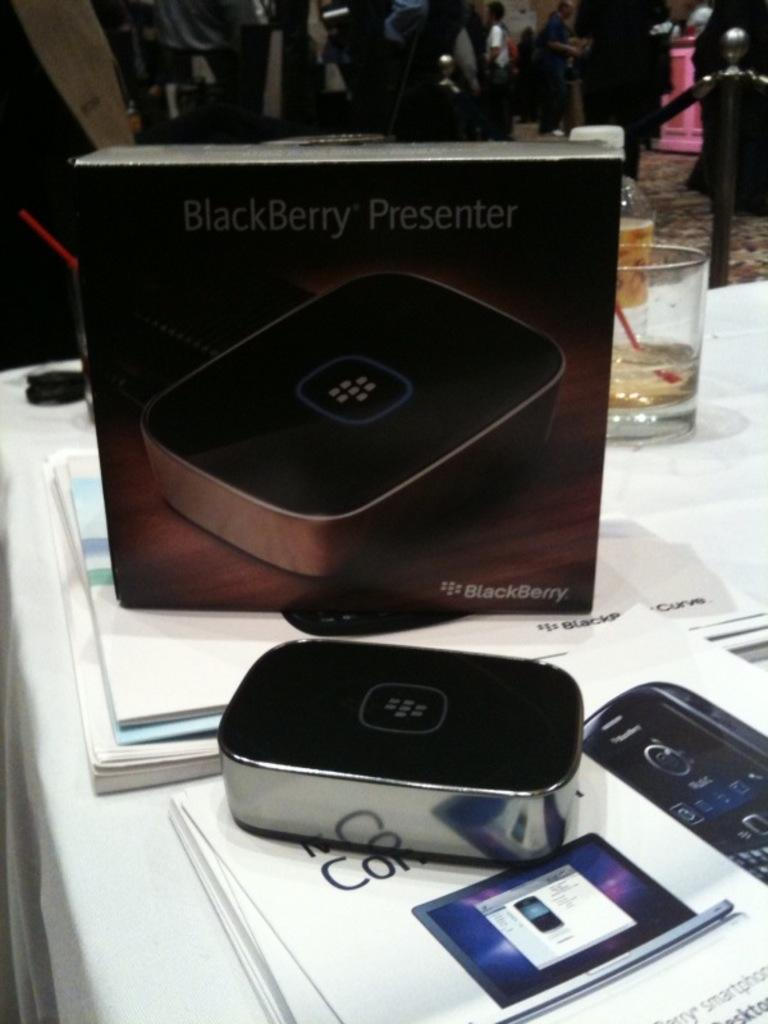<image>
Give a short and clear explanation of the subsequent image. a box that has the word Blackberry on it 